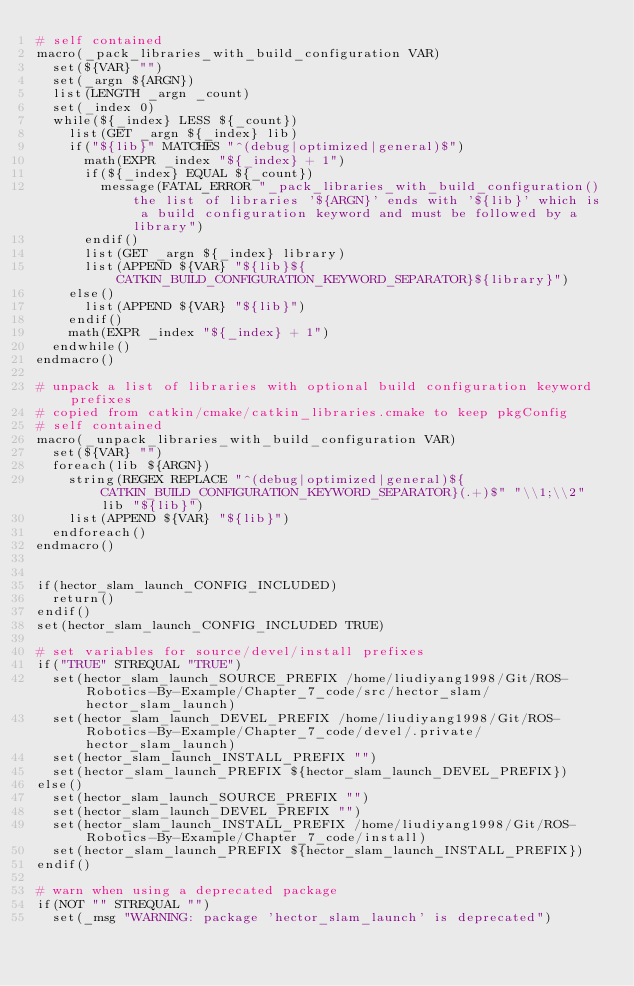Convert code to text. <code><loc_0><loc_0><loc_500><loc_500><_CMake_># self contained
macro(_pack_libraries_with_build_configuration VAR)
  set(${VAR} "")
  set(_argn ${ARGN})
  list(LENGTH _argn _count)
  set(_index 0)
  while(${_index} LESS ${_count})
    list(GET _argn ${_index} lib)
    if("${lib}" MATCHES "^(debug|optimized|general)$")
      math(EXPR _index "${_index} + 1")
      if(${_index} EQUAL ${_count})
        message(FATAL_ERROR "_pack_libraries_with_build_configuration() the list of libraries '${ARGN}' ends with '${lib}' which is a build configuration keyword and must be followed by a library")
      endif()
      list(GET _argn ${_index} library)
      list(APPEND ${VAR} "${lib}${CATKIN_BUILD_CONFIGURATION_KEYWORD_SEPARATOR}${library}")
    else()
      list(APPEND ${VAR} "${lib}")
    endif()
    math(EXPR _index "${_index} + 1")
  endwhile()
endmacro()

# unpack a list of libraries with optional build configuration keyword prefixes
# copied from catkin/cmake/catkin_libraries.cmake to keep pkgConfig
# self contained
macro(_unpack_libraries_with_build_configuration VAR)
  set(${VAR} "")
  foreach(lib ${ARGN})
    string(REGEX REPLACE "^(debug|optimized|general)${CATKIN_BUILD_CONFIGURATION_KEYWORD_SEPARATOR}(.+)$" "\\1;\\2" lib "${lib}")
    list(APPEND ${VAR} "${lib}")
  endforeach()
endmacro()


if(hector_slam_launch_CONFIG_INCLUDED)
  return()
endif()
set(hector_slam_launch_CONFIG_INCLUDED TRUE)

# set variables for source/devel/install prefixes
if("TRUE" STREQUAL "TRUE")
  set(hector_slam_launch_SOURCE_PREFIX /home/liudiyang1998/Git/ROS-Robotics-By-Example/Chapter_7_code/src/hector_slam/hector_slam_launch)
  set(hector_slam_launch_DEVEL_PREFIX /home/liudiyang1998/Git/ROS-Robotics-By-Example/Chapter_7_code/devel/.private/hector_slam_launch)
  set(hector_slam_launch_INSTALL_PREFIX "")
  set(hector_slam_launch_PREFIX ${hector_slam_launch_DEVEL_PREFIX})
else()
  set(hector_slam_launch_SOURCE_PREFIX "")
  set(hector_slam_launch_DEVEL_PREFIX "")
  set(hector_slam_launch_INSTALL_PREFIX /home/liudiyang1998/Git/ROS-Robotics-By-Example/Chapter_7_code/install)
  set(hector_slam_launch_PREFIX ${hector_slam_launch_INSTALL_PREFIX})
endif()

# warn when using a deprecated package
if(NOT "" STREQUAL "")
  set(_msg "WARNING: package 'hector_slam_launch' is deprecated")</code> 